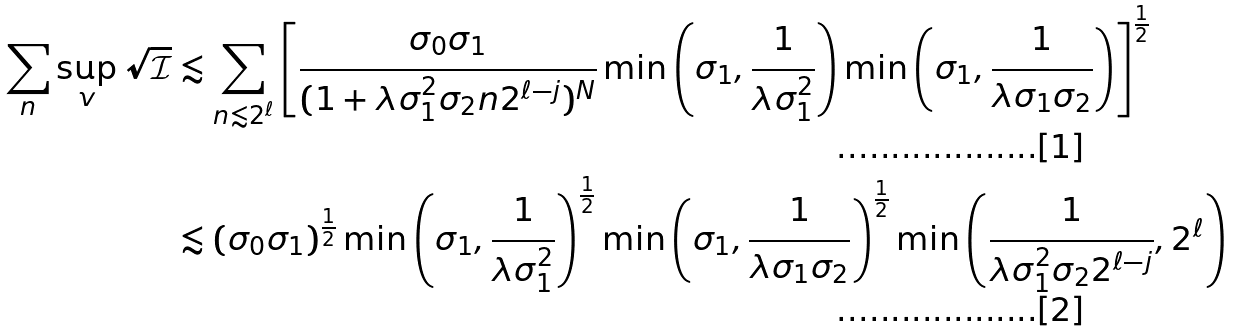Convert formula to latex. <formula><loc_0><loc_0><loc_500><loc_500>\sum _ { n } \sup _ { v } \sqrt { \mathcal { I } } & \lesssim \sum _ { n \lesssim 2 ^ { \ell } } \left [ \frac { \sigma _ { 0 } \sigma _ { 1 } } { ( 1 + \lambda \sigma _ { 1 } ^ { 2 } \sigma _ { 2 } n 2 ^ { \ell - j } ) ^ { N } } \min \left ( \sigma _ { 1 } , \frac { 1 } { \lambda \sigma _ { 1 } ^ { 2 } } \right ) \min \left ( \sigma _ { 1 } , \frac { 1 } { \lambda \sigma _ { 1 } \sigma _ { 2 } } \right ) \right ] ^ { \frac { 1 } { 2 } } \\ & \lesssim ( \sigma _ { 0 } \sigma _ { 1 } ) ^ { \frac { 1 } { 2 } } \min \left ( \sigma _ { 1 } , \frac { 1 } { \lambda \sigma _ { 1 } ^ { 2 } } \right ) ^ { \frac { 1 } { 2 } } \min \left ( \sigma _ { 1 } , \frac { 1 } { \lambda \sigma _ { 1 } \sigma _ { 2 } } \right ) ^ { \frac { 1 } { 2 } } \min \left ( \frac { 1 } { \lambda \sigma _ { 1 } ^ { 2 } \sigma _ { 2 } 2 ^ { \ell - j } } , 2 ^ { \ell } \right )</formula> 